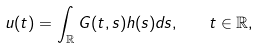Convert formula to latex. <formula><loc_0><loc_0><loc_500><loc_500>u ( t ) = \int _ { \mathbb { R } } G ( t , s ) h ( s ) d s , \quad t \in \mathbb { R } ,</formula> 